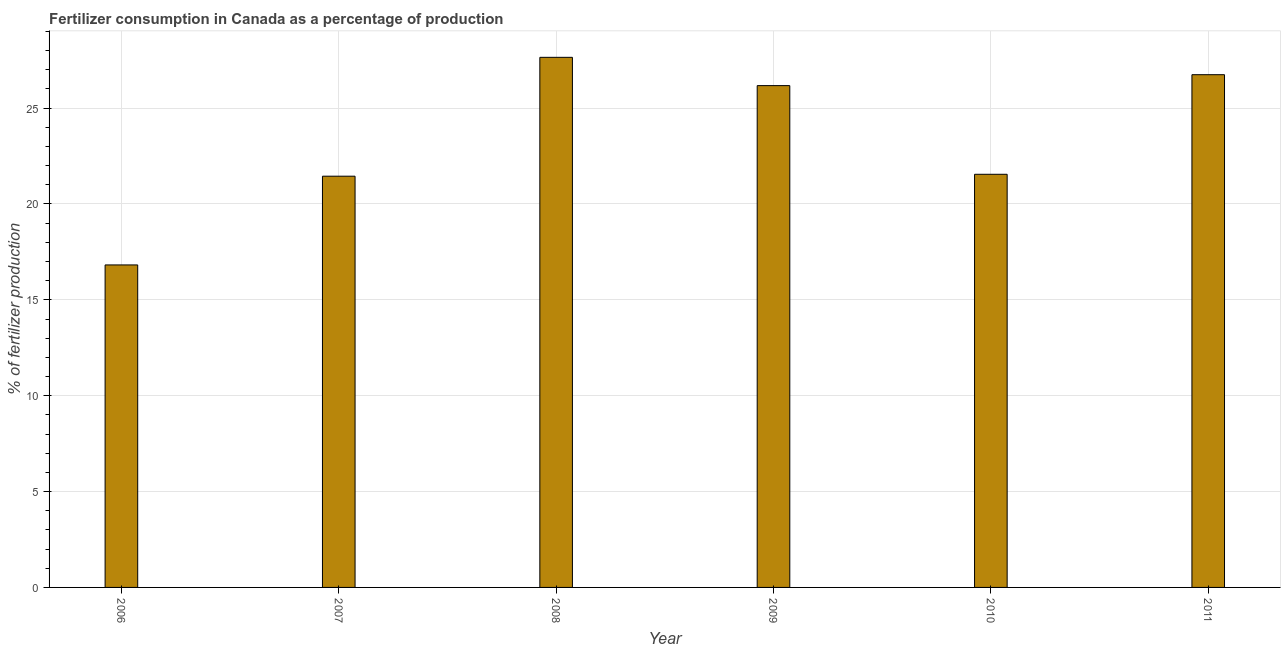Does the graph contain any zero values?
Make the answer very short. No. Does the graph contain grids?
Your answer should be very brief. Yes. What is the title of the graph?
Keep it short and to the point. Fertilizer consumption in Canada as a percentage of production. What is the label or title of the Y-axis?
Make the answer very short. % of fertilizer production. What is the amount of fertilizer consumption in 2008?
Provide a succinct answer. 27.65. Across all years, what is the maximum amount of fertilizer consumption?
Ensure brevity in your answer.  27.65. Across all years, what is the minimum amount of fertilizer consumption?
Provide a short and direct response. 16.82. In which year was the amount of fertilizer consumption maximum?
Your answer should be compact. 2008. In which year was the amount of fertilizer consumption minimum?
Make the answer very short. 2006. What is the sum of the amount of fertilizer consumption?
Make the answer very short. 140.38. What is the difference between the amount of fertilizer consumption in 2007 and 2008?
Keep it short and to the point. -6.2. What is the average amount of fertilizer consumption per year?
Your response must be concise. 23.4. What is the median amount of fertilizer consumption?
Keep it short and to the point. 23.86. In how many years, is the amount of fertilizer consumption greater than 22 %?
Offer a very short reply. 3. Do a majority of the years between 2010 and 2007 (inclusive) have amount of fertilizer consumption greater than 1 %?
Give a very brief answer. Yes. What is the ratio of the amount of fertilizer consumption in 2007 to that in 2011?
Ensure brevity in your answer.  0.8. Is the difference between the amount of fertilizer consumption in 2010 and 2011 greater than the difference between any two years?
Keep it short and to the point. No. What is the difference between the highest and the second highest amount of fertilizer consumption?
Your response must be concise. 0.91. What is the difference between the highest and the lowest amount of fertilizer consumption?
Your response must be concise. 10.83. In how many years, is the amount of fertilizer consumption greater than the average amount of fertilizer consumption taken over all years?
Your answer should be very brief. 3. What is the difference between two consecutive major ticks on the Y-axis?
Offer a terse response. 5. What is the % of fertilizer production of 2006?
Give a very brief answer. 16.82. What is the % of fertilizer production of 2007?
Your answer should be compact. 21.45. What is the % of fertilizer production of 2008?
Provide a short and direct response. 27.65. What is the % of fertilizer production in 2009?
Provide a short and direct response. 26.17. What is the % of fertilizer production of 2010?
Provide a short and direct response. 21.55. What is the % of fertilizer production in 2011?
Offer a very short reply. 26.74. What is the difference between the % of fertilizer production in 2006 and 2007?
Your answer should be compact. -4.63. What is the difference between the % of fertilizer production in 2006 and 2008?
Your answer should be compact. -10.83. What is the difference between the % of fertilizer production in 2006 and 2009?
Give a very brief answer. -9.35. What is the difference between the % of fertilizer production in 2006 and 2010?
Offer a terse response. -4.73. What is the difference between the % of fertilizer production in 2006 and 2011?
Your answer should be very brief. -9.92. What is the difference between the % of fertilizer production in 2007 and 2008?
Provide a short and direct response. -6.2. What is the difference between the % of fertilizer production in 2007 and 2009?
Provide a succinct answer. -4.72. What is the difference between the % of fertilizer production in 2007 and 2010?
Keep it short and to the point. -0.1. What is the difference between the % of fertilizer production in 2007 and 2011?
Keep it short and to the point. -5.29. What is the difference between the % of fertilizer production in 2008 and 2009?
Make the answer very short. 1.48. What is the difference between the % of fertilizer production in 2008 and 2010?
Give a very brief answer. 6.1. What is the difference between the % of fertilizer production in 2008 and 2011?
Give a very brief answer. 0.91. What is the difference between the % of fertilizer production in 2009 and 2010?
Offer a very short reply. 4.63. What is the difference between the % of fertilizer production in 2009 and 2011?
Your answer should be very brief. -0.57. What is the difference between the % of fertilizer production in 2010 and 2011?
Offer a terse response. -5.2. What is the ratio of the % of fertilizer production in 2006 to that in 2007?
Your response must be concise. 0.78. What is the ratio of the % of fertilizer production in 2006 to that in 2008?
Your answer should be compact. 0.61. What is the ratio of the % of fertilizer production in 2006 to that in 2009?
Keep it short and to the point. 0.64. What is the ratio of the % of fertilizer production in 2006 to that in 2010?
Offer a terse response. 0.78. What is the ratio of the % of fertilizer production in 2006 to that in 2011?
Provide a short and direct response. 0.63. What is the ratio of the % of fertilizer production in 2007 to that in 2008?
Offer a terse response. 0.78. What is the ratio of the % of fertilizer production in 2007 to that in 2009?
Give a very brief answer. 0.82. What is the ratio of the % of fertilizer production in 2007 to that in 2011?
Offer a very short reply. 0.8. What is the ratio of the % of fertilizer production in 2008 to that in 2009?
Ensure brevity in your answer.  1.06. What is the ratio of the % of fertilizer production in 2008 to that in 2010?
Offer a very short reply. 1.28. What is the ratio of the % of fertilizer production in 2008 to that in 2011?
Provide a short and direct response. 1.03. What is the ratio of the % of fertilizer production in 2009 to that in 2010?
Provide a succinct answer. 1.22. What is the ratio of the % of fertilizer production in 2010 to that in 2011?
Your answer should be very brief. 0.81. 